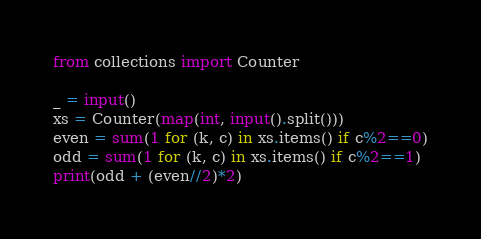<code> <loc_0><loc_0><loc_500><loc_500><_Python_>from collections import Counter

_ = input()
xs = Counter(map(int, input().split()))
even = sum(1 for (k, c) in xs.items() if c%2==0)
odd = sum(1 for (k, c) in xs.items() if c%2==1)
print(odd + (even//2)*2)</code> 